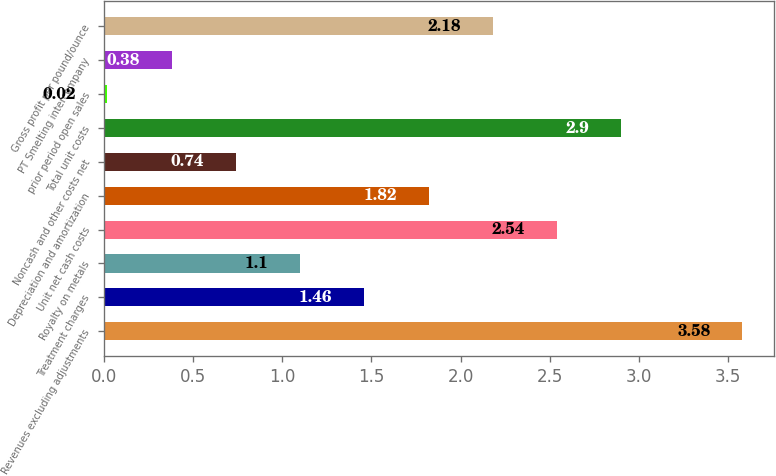<chart> <loc_0><loc_0><loc_500><loc_500><bar_chart><fcel>Revenues excluding adjustments<fcel>Treatment charges<fcel>Royalty on metals<fcel>Unit net cash costs<fcel>Depreciation and amortization<fcel>Noncash and other costs net<fcel>Total unit costs<fcel>prior period open sales<fcel>PT Smelting intercompany<fcel>Gross profit per pound/ounce<nl><fcel>3.58<fcel>1.46<fcel>1.1<fcel>2.54<fcel>1.82<fcel>0.74<fcel>2.9<fcel>0.02<fcel>0.38<fcel>2.18<nl></chart> 